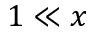Convert formula to latex. <formula><loc_0><loc_0><loc_500><loc_500>{ 1 \ll x }</formula> 